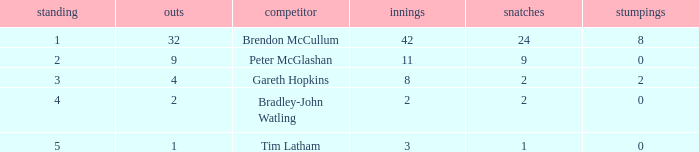How many dismissals did the player Peter McGlashan have? 9.0. 